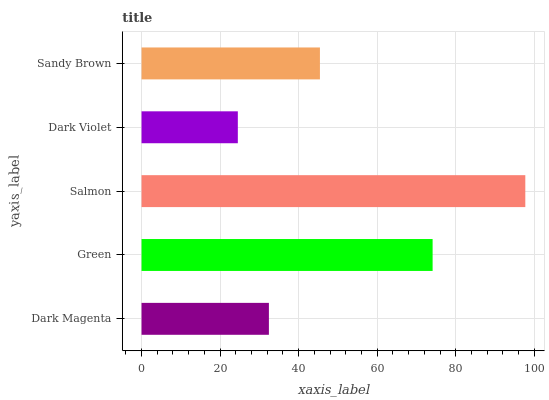Is Dark Violet the minimum?
Answer yes or no. Yes. Is Salmon the maximum?
Answer yes or no. Yes. Is Green the minimum?
Answer yes or no. No. Is Green the maximum?
Answer yes or no. No. Is Green greater than Dark Magenta?
Answer yes or no. Yes. Is Dark Magenta less than Green?
Answer yes or no. Yes. Is Dark Magenta greater than Green?
Answer yes or no. No. Is Green less than Dark Magenta?
Answer yes or no. No. Is Sandy Brown the high median?
Answer yes or no. Yes. Is Sandy Brown the low median?
Answer yes or no. Yes. Is Dark Magenta the high median?
Answer yes or no. No. Is Dark Magenta the low median?
Answer yes or no. No. 